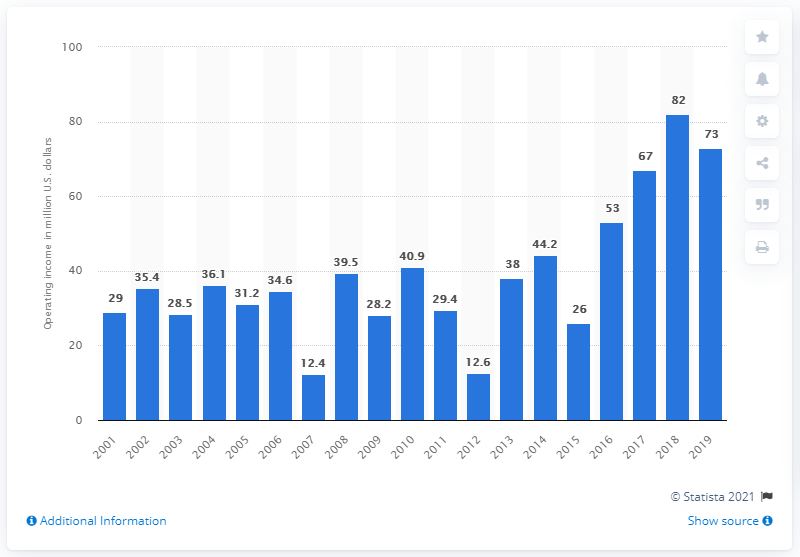Identify some key points in this picture. The operating income of the Buffalo Bills during the 2019 season was $73 million. 